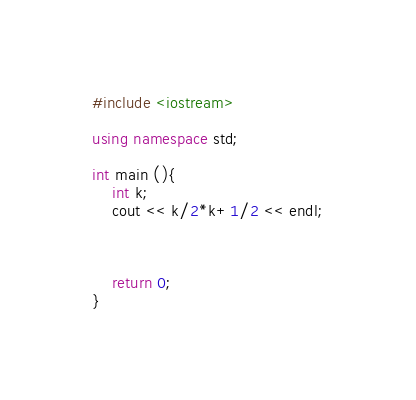Convert code to text. <code><loc_0><loc_0><loc_500><loc_500><_C++_>#include <iostream>

using namespace std;

int main (){
	int k;
	cout << k/2*k+1/2 << endl;
	
	
	
	return 0;
}</code> 